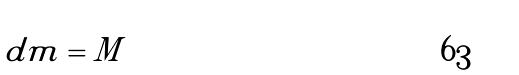Convert formula to latex. <formula><loc_0><loc_0><loc_500><loc_500>\int d m = M</formula> 